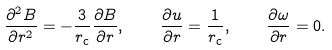Convert formula to latex. <formula><loc_0><loc_0><loc_500><loc_500>\frac { \partial ^ { 2 } B } { \partial r ^ { 2 } } = - \frac { 3 } { r _ { \text  c}}\frac{\partial B}{\partial r}, \quad \frac{\partial u}{\partial r}   = \frac{1}{r_{\text  c}}, \quad \frac{\partial \omega}{\partial r}   = 0.</formula> 